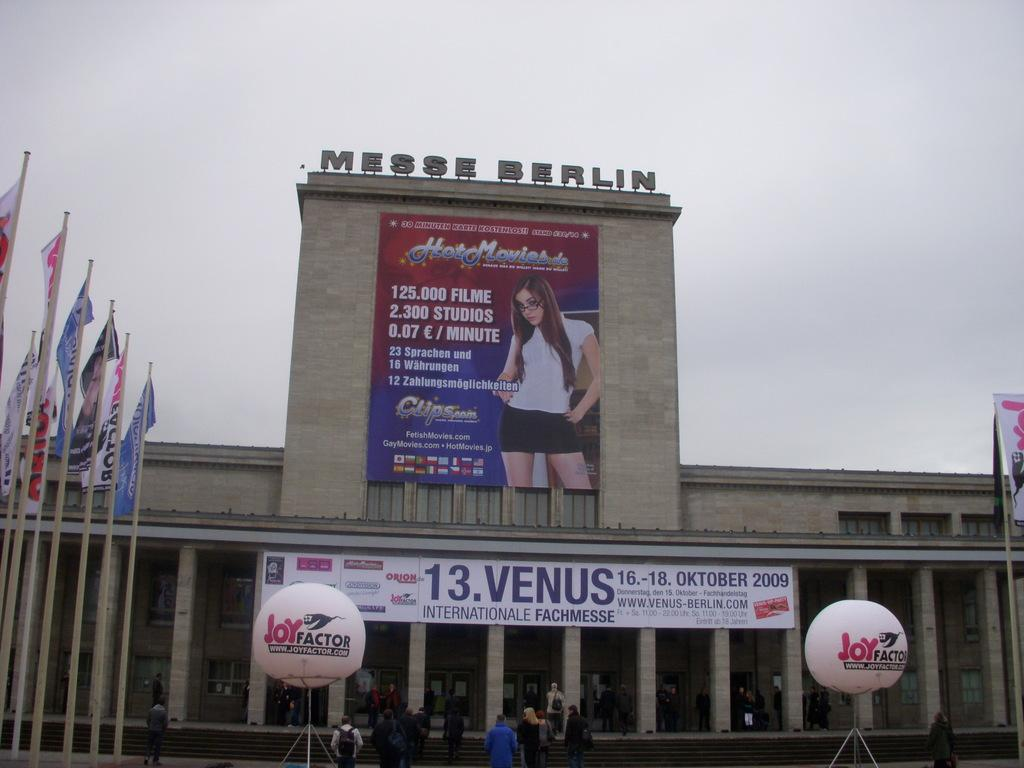<image>
Give a short and clear explanation of the subsequent image. A sign for Hot Movies is on display in Messe Berlin 